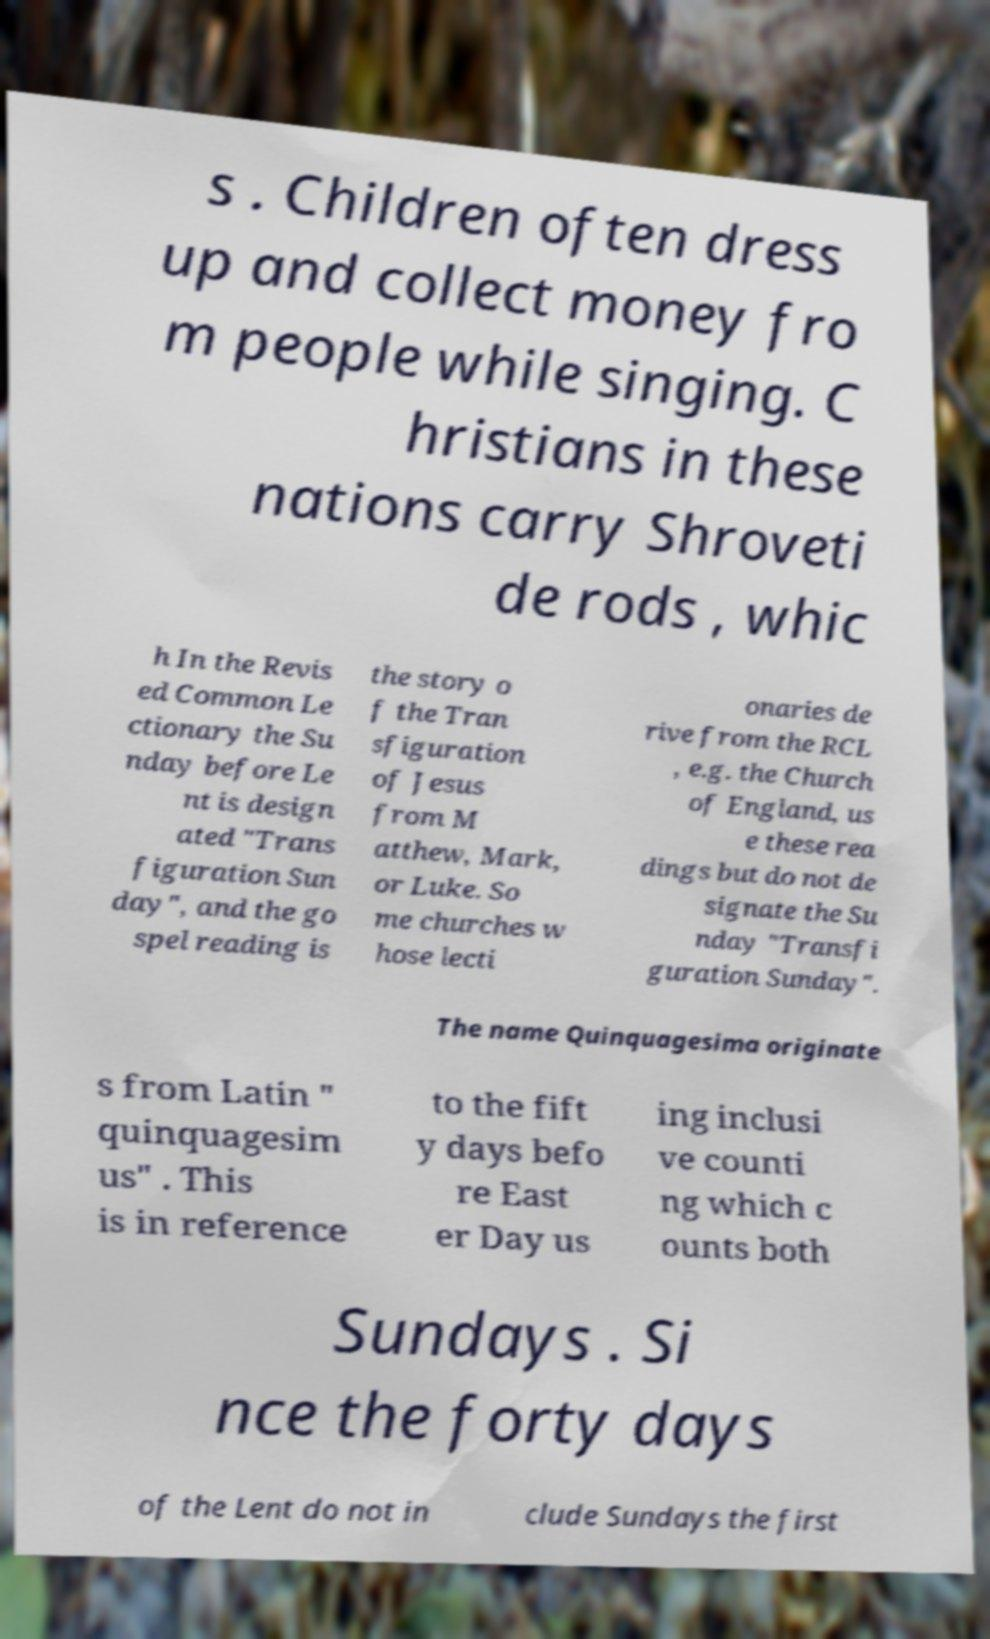Can you read and provide the text displayed in the image?This photo seems to have some interesting text. Can you extract and type it out for me? s . Children often dress up and collect money fro m people while singing. C hristians in these nations carry Shroveti de rods , whic h In the Revis ed Common Le ctionary the Su nday before Le nt is design ated "Trans figuration Sun day", and the go spel reading is the story o f the Tran sfiguration of Jesus from M atthew, Mark, or Luke. So me churches w hose lecti onaries de rive from the RCL , e.g. the Church of England, us e these rea dings but do not de signate the Su nday "Transfi guration Sunday". The name Quinquagesima originate s from Latin " quinquagesim us" . This is in reference to the fift y days befo re East er Day us ing inclusi ve counti ng which c ounts both Sundays . Si nce the forty days of the Lent do not in clude Sundays the first 